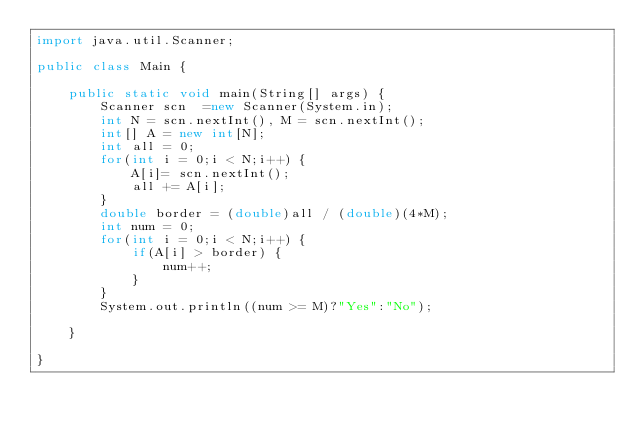Convert code to text. <code><loc_0><loc_0><loc_500><loc_500><_Java_>import java.util.Scanner;

public class Main {

	public static void main(String[] args) {
		Scanner scn  =new Scanner(System.in);
		int N = scn.nextInt(), M = scn.nextInt();
		int[] A = new int[N];
		int all = 0;
		for(int i = 0;i < N;i++) {
			A[i]= scn.nextInt();
			all += A[i];
		}
		double border = (double)all / (double)(4*M);
		int num = 0;
		for(int i = 0;i < N;i++) {
			if(A[i] > border) {
				num++;
			}
		}
		System.out.println((num >= M)?"Yes":"No");

	}

}
</code> 